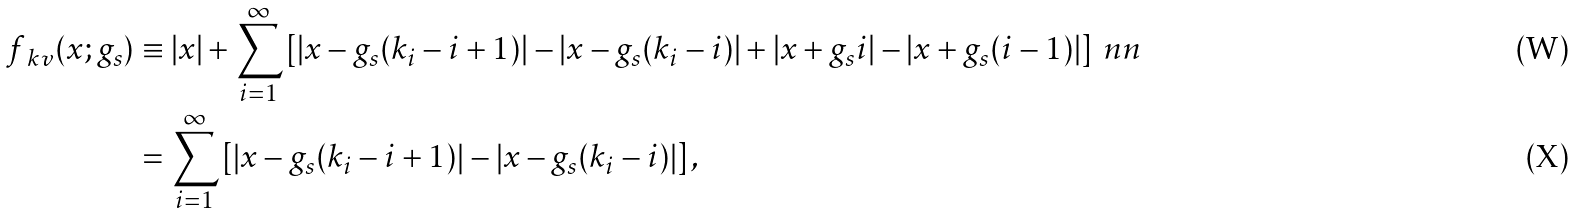Convert formula to latex. <formula><loc_0><loc_0><loc_500><loc_500>f _ { \ k v } ( x ; g _ { s } ) & \equiv | x | + \sum _ { i = 1 } ^ { \infty } \left [ | x - g _ { s } ( k _ { i } - i + 1 ) | - | x - g _ { s } ( k _ { i } - i ) | + | x + g _ { s } i | - | x + g _ { s } ( i - 1 ) | \right ] \ n n \\ & = \sum _ { i = 1 } ^ { \infty } \left [ \left | x - g _ { s } ( k _ { i } - i + 1 ) \right | - \left | x - g _ { s } ( k _ { i } - i ) \right | \right ] ,</formula> 